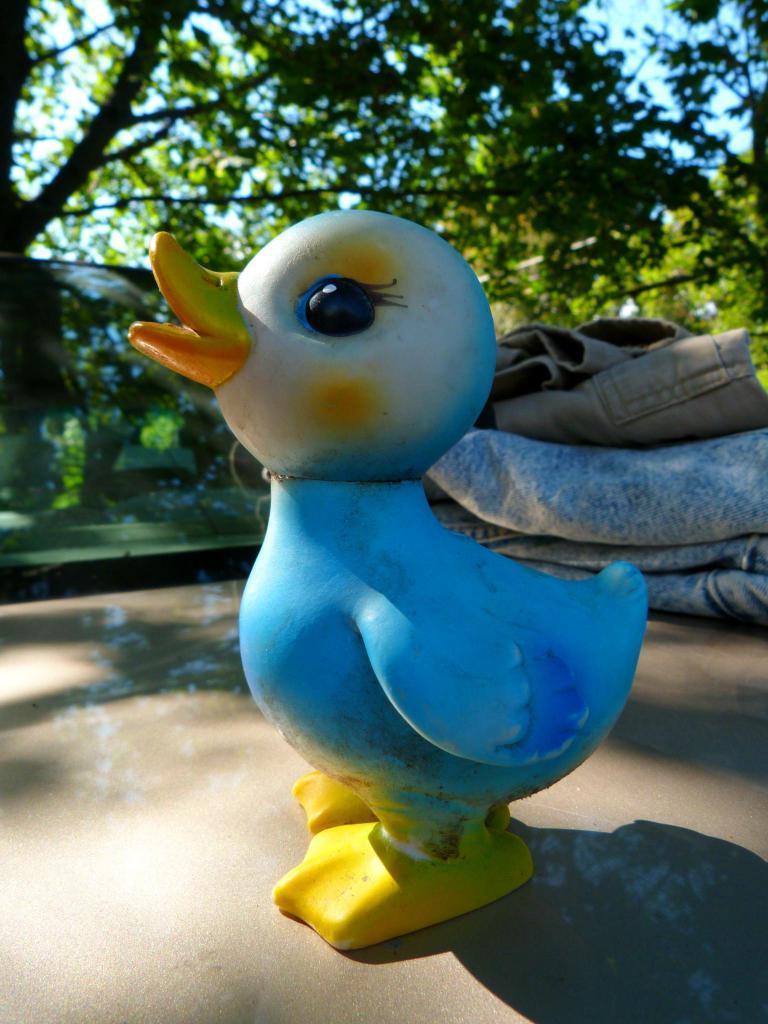Could you give a brief overview of what you see in this image? In the image I can see a bird shaped toy. In the background I can clothes, trees and the sky. 